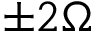<formula> <loc_0><loc_0><loc_500><loc_500>\pm 2 \Omega</formula> 